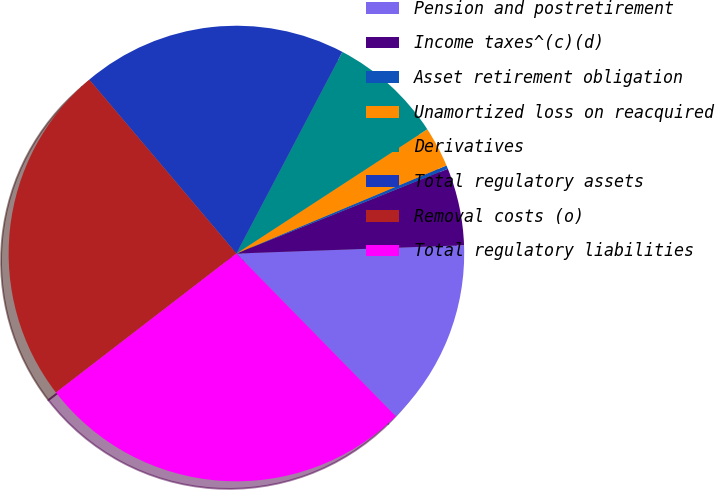Convert chart to OTSL. <chart><loc_0><loc_0><loc_500><loc_500><pie_chart><fcel>Pension and postretirement<fcel>Income taxes^(c)(d)<fcel>Asset retirement obligation<fcel>Unamortized loss on reacquired<fcel>Derivatives<fcel>Total regulatory assets<fcel>Removal costs (o)<fcel>Total regulatory liabilities<nl><fcel>13.24%<fcel>5.49%<fcel>0.25%<fcel>2.87%<fcel>8.11%<fcel>18.88%<fcel>24.27%<fcel>26.89%<nl></chart> 